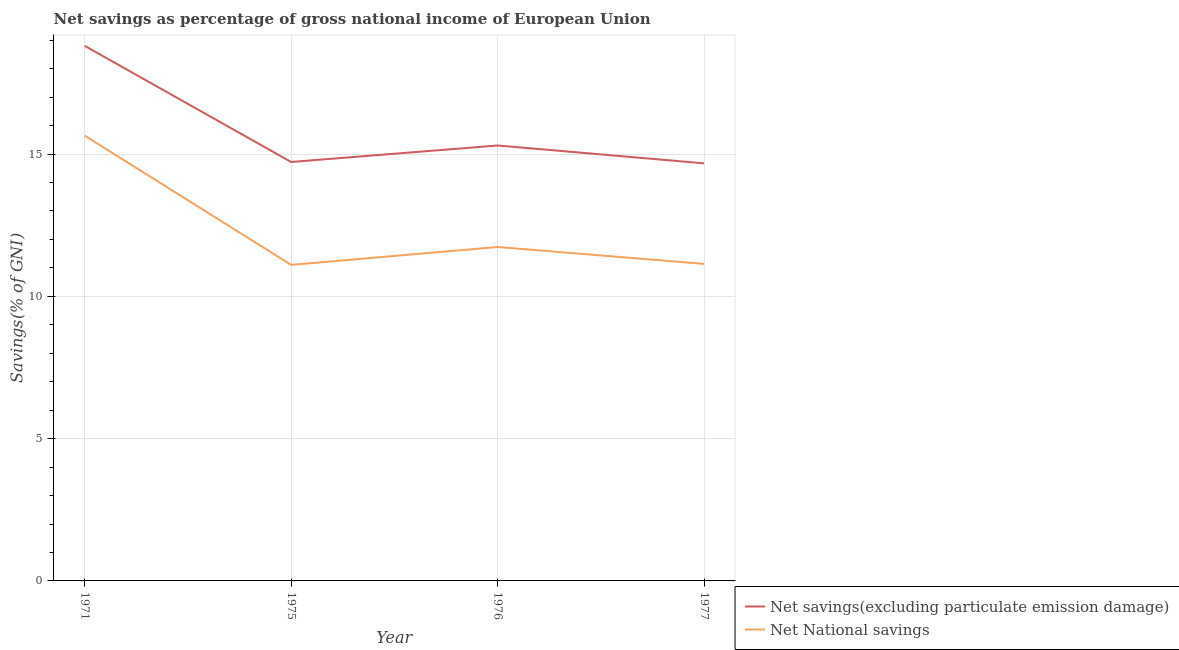What is the net savings(excluding particulate emission damage) in 1975?
Make the answer very short. 14.72. Across all years, what is the maximum net national savings?
Your answer should be compact. 15.65. Across all years, what is the minimum net national savings?
Your answer should be very brief. 11.11. What is the total net national savings in the graph?
Your response must be concise. 49.63. What is the difference between the net national savings in 1976 and that in 1977?
Make the answer very short. 0.59. What is the difference between the net national savings in 1975 and the net savings(excluding particulate emission damage) in 1976?
Provide a succinct answer. -4.2. What is the average net national savings per year?
Make the answer very short. 12.41. In the year 1976, what is the difference between the net national savings and net savings(excluding particulate emission damage)?
Your response must be concise. -3.57. What is the ratio of the net national savings in 1976 to that in 1977?
Offer a terse response. 1.05. Is the net national savings in 1975 less than that in 1976?
Provide a succinct answer. Yes. What is the difference between the highest and the second highest net national savings?
Your answer should be compact. 3.91. What is the difference between the highest and the lowest net national savings?
Offer a terse response. 4.54. In how many years, is the net savings(excluding particulate emission damage) greater than the average net savings(excluding particulate emission damage) taken over all years?
Keep it short and to the point. 1. Is the net savings(excluding particulate emission damage) strictly less than the net national savings over the years?
Your answer should be very brief. No. How many years are there in the graph?
Keep it short and to the point. 4. Are the values on the major ticks of Y-axis written in scientific E-notation?
Your response must be concise. No. Does the graph contain any zero values?
Give a very brief answer. No. Where does the legend appear in the graph?
Keep it short and to the point. Bottom right. How many legend labels are there?
Your answer should be compact. 2. What is the title of the graph?
Provide a succinct answer. Net savings as percentage of gross national income of European Union. What is the label or title of the X-axis?
Provide a short and direct response. Year. What is the label or title of the Y-axis?
Provide a succinct answer. Savings(% of GNI). What is the Savings(% of GNI) in Net savings(excluding particulate emission damage) in 1971?
Offer a terse response. 18.8. What is the Savings(% of GNI) in Net National savings in 1971?
Make the answer very short. 15.65. What is the Savings(% of GNI) of Net savings(excluding particulate emission damage) in 1975?
Provide a succinct answer. 14.72. What is the Savings(% of GNI) in Net National savings in 1975?
Make the answer very short. 11.11. What is the Savings(% of GNI) in Net savings(excluding particulate emission damage) in 1976?
Give a very brief answer. 15.3. What is the Savings(% of GNI) in Net National savings in 1976?
Offer a terse response. 11.73. What is the Savings(% of GNI) in Net savings(excluding particulate emission damage) in 1977?
Ensure brevity in your answer.  14.67. What is the Savings(% of GNI) of Net National savings in 1977?
Provide a succinct answer. 11.14. Across all years, what is the maximum Savings(% of GNI) in Net savings(excluding particulate emission damage)?
Give a very brief answer. 18.8. Across all years, what is the maximum Savings(% of GNI) of Net National savings?
Provide a short and direct response. 15.65. Across all years, what is the minimum Savings(% of GNI) of Net savings(excluding particulate emission damage)?
Offer a very short reply. 14.67. Across all years, what is the minimum Savings(% of GNI) in Net National savings?
Keep it short and to the point. 11.11. What is the total Savings(% of GNI) in Net savings(excluding particulate emission damage) in the graph?
Offer a very short reply. 63.5. What is the total Savings(% of GNI) of Net National savings in the graph?
Keep it short and to the point. 49.63. What is the difference between the Savings(% of GNI) of Net savings(excluding particulate emission damage) in 1971 and that in 1975?
Ensure brevity in your answer.  4.08. What is the difference between the Savings(% of GNI) of Net National savings in 1971 and that in 1975?
Offer a terse response. 4.54. What is the difference between the Savings(% of GNI) of Net savings(excluding particulate emission damage) in 1971 and that in 1976?
Keep it short and to the point. 3.5. What is the difference between the Savings(% of GNI) of Net National savings in 1971 and that in 1976?
Your response must be concise. 3.91. What is the difference between the Savings(% of GNI) of Net savings(excluding particulate emission damage) in 1971 and that in 1977?
Provide a short and direct response. 4.13. What is the difference between the Savings(% of GNI) in Net National savings in 1971 and that in 1977?
Provide a succinct answer. 4.51. What is the difference between the Savings(% of GNI) of Net savings(excluding particulate emission damage) in 1975 and that in 1976?
Provide a short and direct response. -0.58. What is the difference between the Savings(% of GNI) of Net National savings in 1975 and that in 1976?
Provide a succinct answer. -0.63. What is the difference between the Savings(% of GNI) in Net savings(excluding particulate emission damage) in 1975 and that in 1977?
Provide a short and direct response. 0.05. What is the difference between the Savings(% of GNI) of Net National savings in 1975 and that in 1977?
Your response must be concise. -0.03. What is the difference between the Savings(% of GNI) in Net savings(excluding particulate emission damage) in 1976 and that in 1977?
Your answer should be very brief. 0.63. What is the difference between the Savings(% of GNI) in Net National savings in 1976 and that in 1977?
Give a very brief answer. 0.59. What is the difference between the Savings(% of GNI) of Net savings(excluding particulate emission damage) in 1971 and the Savings(% of GNI) of Net National savings in 1975?
Provide a succinct answer. 7.7. What is the difference between the Savings(% of GNI) in Net savings(excluding particulate emission damage) in 1971 and the Savings(% of GNI) in Net National savings in 1976?
Provide a short and direct response. 7.07. What is the difference between the Savings(% of GNI) in Net savings(excluding particulate emission damage) in 1971 and the Savings(% of GNI) in Net National savings in 1977?
Give a very brief answer. 7.66. What is the difference between the Savings(% of GNI) of Net savings(excluding particulate emission damage) in 1975 and the Savings(% of GNI) of Net National savings in 1976?
Your response must be concise. 2.99. What is the difference between the Savings(% of GNI) of Net savings(excluding particulate emission damage) in 1975 and the Savings(% of GNI) of Net National savings in 1977?
Provide a short and direct response. 3.58. What is the difference between the Savings(% of GNI) of Net savings(excluding particulate emission damage) in 1976 and the Savings(% of GNI) of Net National savings in 1977?
Your response must be concise. 4.16. What is the average Savings(% of GNI) in Net savings(excluding particulate emission damage) per year?
Your answer should be very brief. 15.88. What is the average Savings(% of GNI) of Net National savings per year?
Provide a succinct answer. 12.41. In the year 1971, what is the difference between the Savings(% of GNI) of Net savings(excluding particulate emission damage) and Savings(% of GNI) of Net National savings?
Give a very brief answer. 3.16. In the year 1975, what is the difference between the Savings(% of GNI) of Net savings(excluding particulate emission damage) and Savings(% of GNI) of Net National savings?
Offer a very short reply. 3.62. In the year 1976, what is the difference between the Savings(% of GNI) of Net savings(excluding particulate emission damage) and Savings(% of GNI) of Net National savings?
Provide a succinct answer. 3.57. In the year 1977, what is the difference between the Savings(% of GNI) of Net savings(excluding particulate emission damage) and Savings(% of GNI) of Net National savings?
Your answer should be compact. 3.53. What is the ratio of the Savings(% of GNI) in Net savings(excluding particulate emission damage) in 1971 to that in 1975?
Your response must be concise. 1.28. What is the ratio of the Savings(% of GNI) in Net National savings in 1971 to that in 1975?
Give a very brief answer. 1.41. What is the ratio of the Savings(% of GNI) in Net savings(excluding particulate emission damage) in 1971 to that in 1976?
Keep it short and to the point. 1.23. What is the ratio of the Savings(% of GNI) in Net National savings in 1971 to that in 1976?
Offer a very short reply. 1.33. What is the ratio of the Savings(% of GNI) of Net savings(excluding particulate emission damage) in 1971 to that in 1977?
Offer a terse response. 1.28. What is the ratio of the Savings(% of GNI) of Net National savings in 1971 to that in 1977?
Your answer should be compact. 1.4. What is the ratio of the Savings(% of GNI) in Net savings(excluding particulate emission damage) in 1975 to that in 1976?
Your answer should be very brief. 0.96. What is the ratio of the Savings(% of GNI) of Net National savings in 1975 to that in 1976?
Your response must be concise. 0.95. What is the ratio of the Savings(% of GNI) in Net savings(excluding particulate emission damage) in 1975 to that in 1977?
Offer a very short reply. 1. What is the ratio of the Savings(% of GNI) of Net savings(excluding particulate emission damage) in 1976 to that in 1977?
Provide a short and direct response. 1.04. What is the ratio of the Savings(% of GNI) of Net National savings in 1976 to that in 1977?
Give a very brief answer. 1.05. What is the difference between the highest and the second highest Savings(% of GNI) in Net savings(excluding particulate emission damage)?
Provide a short and direct response. 3.5. What is the difference between the highest and the second highest Savings(% of GNI) of Net National savings?
Keep it short and to the point. 3.91. What is the difference between the highest and the lowest Savings(% of GNI) in Net savings(excluding particulate emission damage)?
Ensure brevity in your answer.  4.13. What is the difference between the highest and the lowest Savings(% of GNI) of Net National savings?
Ensure brevity in your answer.  4.54. 